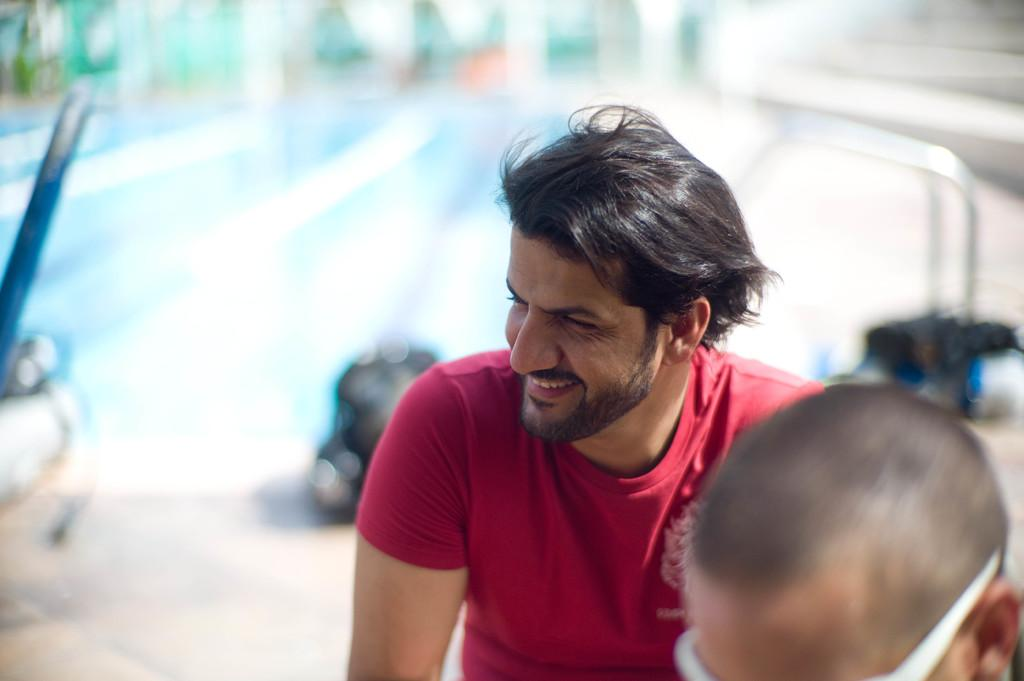What is the main subject of the image? There is a man in the image. What is the man wearing? The man is wearing a red t-shirt. What expression does the man have? The man is smiling. Can you tell me how the man's tongue is reacting to the earthquake in the image? There is no earthquake or any indication of the man's tongue in the image. 